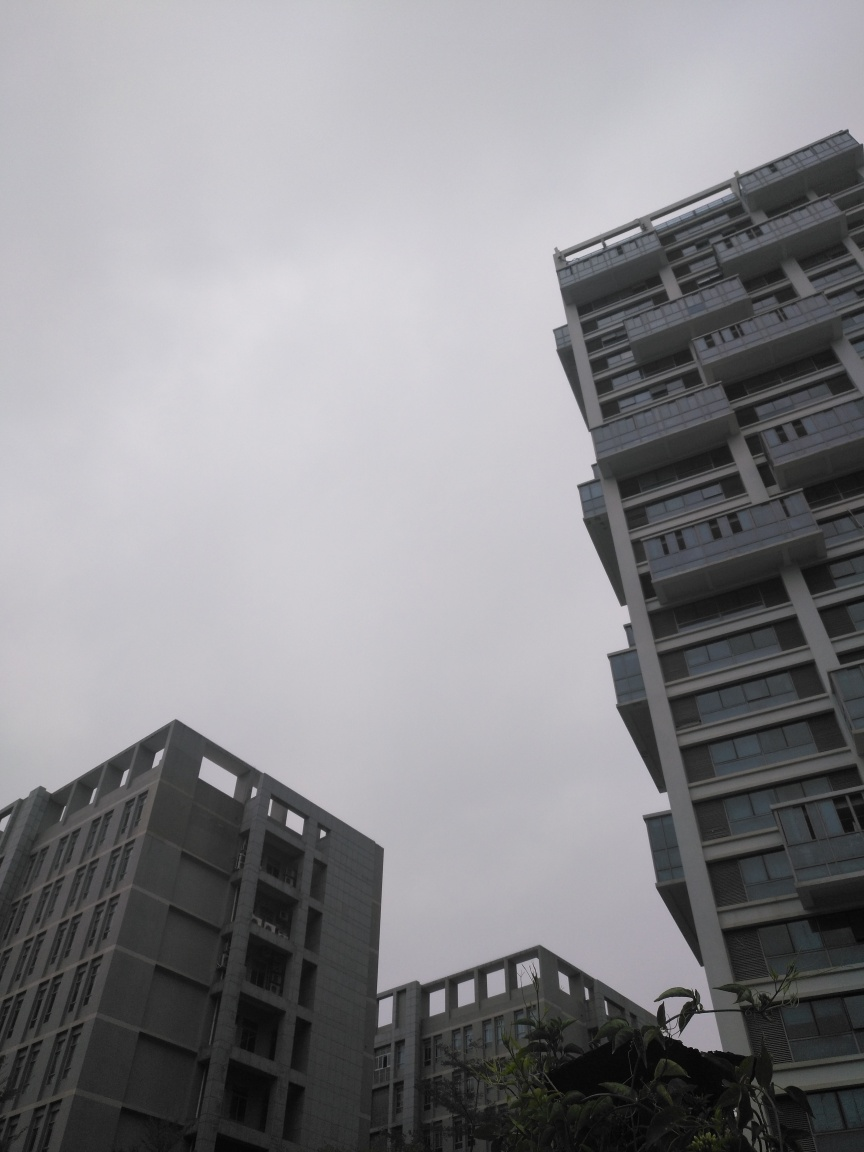What can you tell me about the architectural styles visible in this image? The buildings in the image exhibit characteristics of modern architecture, primarily using geometric forms and incorporating elements like horizontal windows and terraces. These styles suggest a focus on functionality while maintaining an aesthetic of minimalism. The façades are composed of glass and concrete, which are commonly used materials in contemporary urban design. 